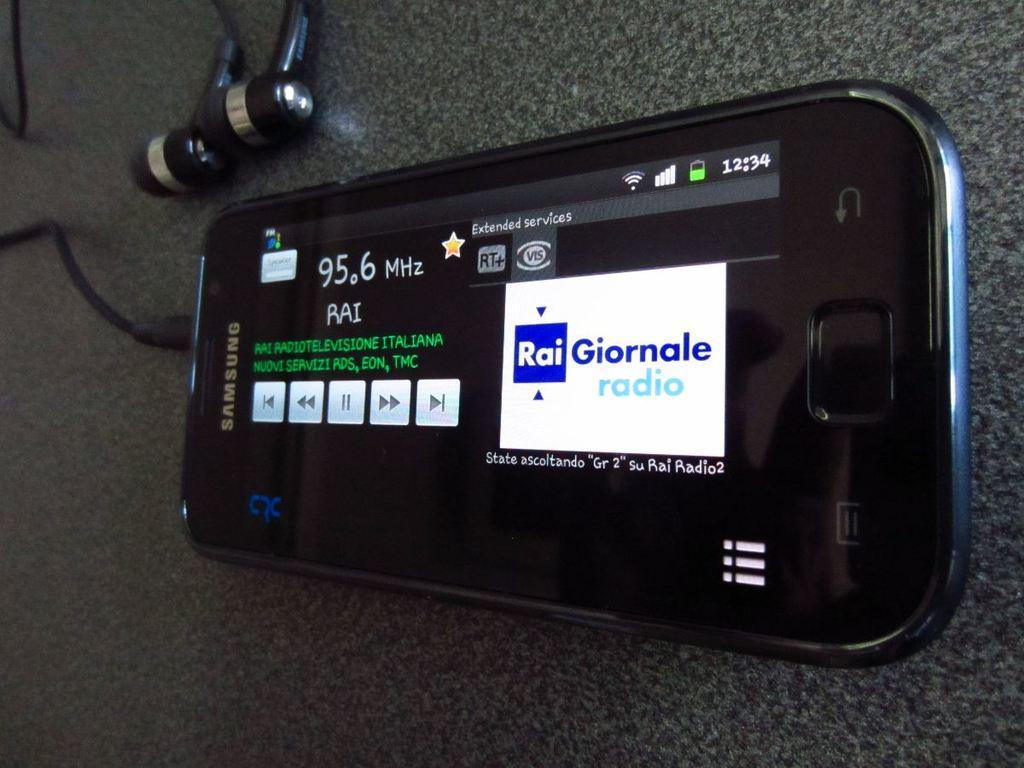Please provide a concise description of this image. In this image we can see a device with screen on which we can see some text is placed on the surface. At the top left corner of the image we can see earphones. 